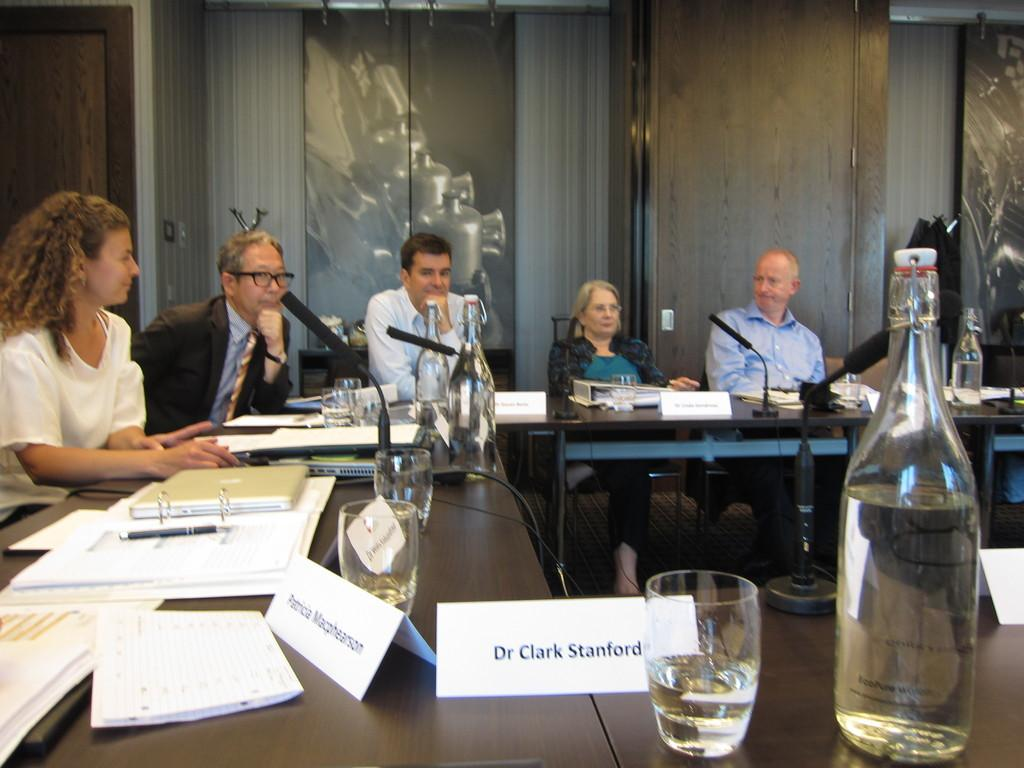Provide a one-sentence caption for the provided image. a dr. clark stanford name tag on the desk. 